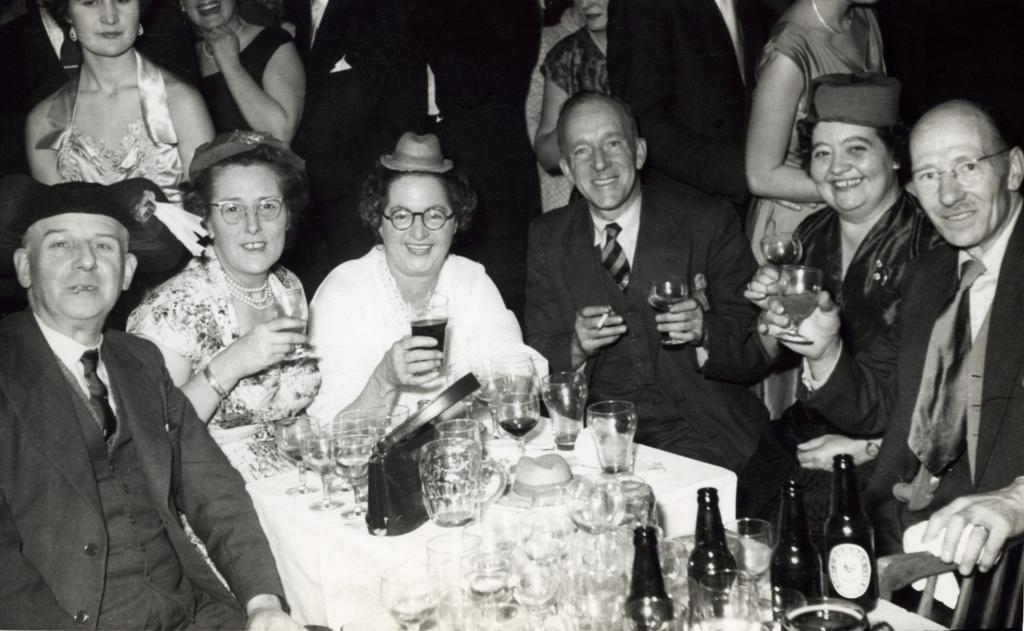Describe this image in one or two sentences. The image is in black and white we can see there are group of people sitting and smiling, in front there is a table, glasses, wine bottles on it, at the back there are a group of people standing. 